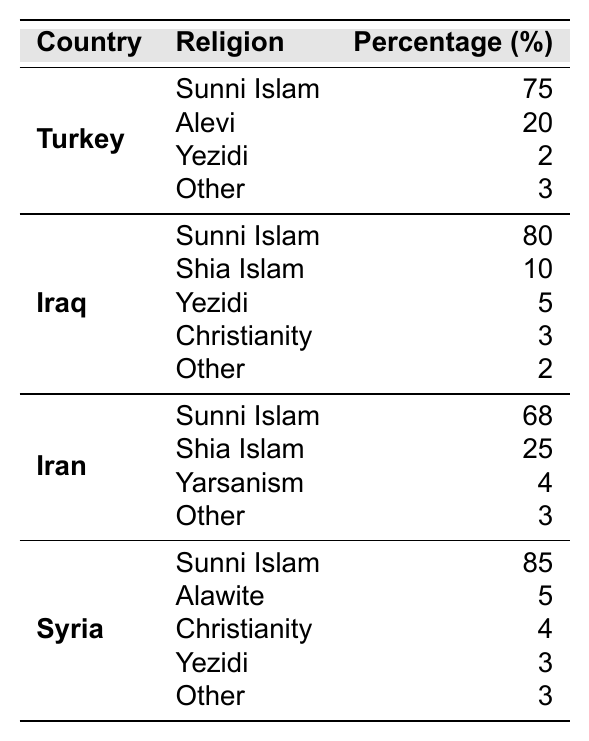What is the percentage of Sunni Islam in Iraq? The table shows that the percentage of Sunni Islam in Iraq is listed directly under the Iraq section. From the data, it shows as 80%.
Answer: 80% Which Kurdish population has the highest percentage of Yezidi followers? By examining the Yezidi religious affiliation percentages in each country, Turkey has 2%, Iraq has 5%, Iran has 0%, and Syria has 3%. The highest is 5% in Iraq.
Answer: Iraq How does the percentage of Shia Islam in Iran compare to that in Iraq? The table shows Shia Islam in Iran at 25% and in Iraq at 10%. Comparing these two values indicates that Iran has a higher percentage of Shia Islam by 15%.
Answer: 15% What is the total percentage of religions classified as "Other" among the Kurdish populations in Turkey? In Turkey, the accompanying religions classified as "Other" amounts to 3%. There are no additional categories under Turkey.
Answer: 3% True or False: Christianity is more prevalent among the Kurdish population in Iraq than in Syria. The table shows that Christianity is represented by 3% in Iraq and 4% in Syria. Since 4% is greater than 3%, the statement is false.
Answer: False What is the average percentage of Sunni Islam across all four countries listed? The percentages of Sunni Islam are 75% in Turkey, 80% in Iraq, 68% in Iran, and 85% in Syria. The sum is 75 + 80 + 68 + 85 = 308, and with four groups, the average is 308 / 4 = 77%.
Answer: 77% Which country has the lowest percentage of Shia Islam? Upon looking at the data for Shia Islam percentages, Iraq has 10% and Iran has 25%. Thus, Iraq has the lowest percentage of Shia Islam.
Answer: Iraq Calculate the difference in the percentage of Sunni Islam between Turkey and Syria. The percentage of Sunni Islam in Turkey is 75%, while in Syria, it is 85%. The difference is 85% - 75% = 10%.
Answer: 10% Is the total percentage of Sunni Islam greater than 75% among all Kurdish populations? For total Sunni Islam, we add the percentages: 75% in Turkey + 80% in Iraq + 68% in Iran + 85% in Syria = 308%. Since 308% is definitely greater than 75%, the statement is true.
Answer: True What is the combined percentage of Alawite and Other religions in Syria? In Syria, Alawite is at 5% and Other is also at 3%. Therefore, the combined percentage is 5% + 3% = 8%.
Answer: 8% 